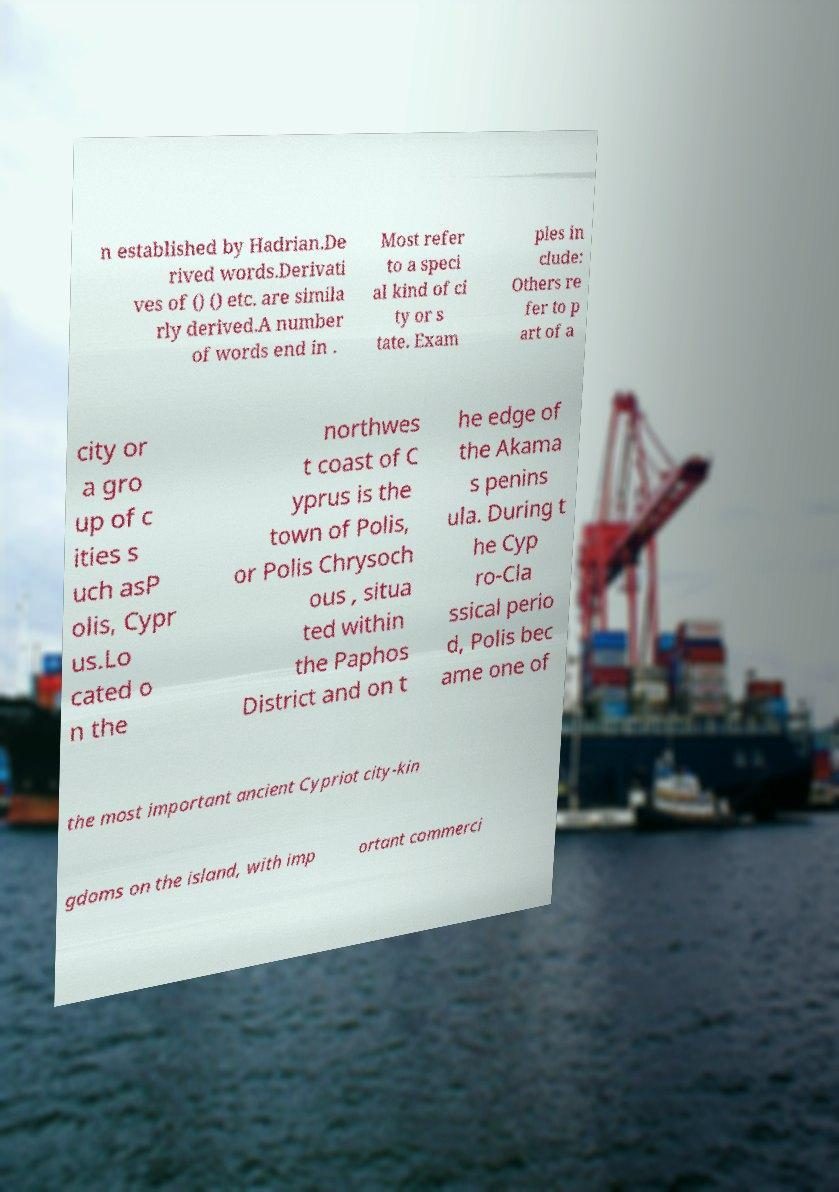I need the written content from this picture converted into text. Can you do that? n established by Hadrian.De rived words.Derivati ves of () () etc. are simila rly derived.A number of words end in . Most refer to a speci al kind of ci ty or s tate. Exam ples in clude: Others re fer to p art of a city or a gro up of c ities s uch asP olis, Cypr us.Lo cated o n the northwes t coast of C yprus is the town of Polis, or Polis Chrysoch ous , situa ted within the Paphos District and on t he edge of the Akama s penins ula. During t he Cyp ro-Cla ssical perio d, Polis bec ame one of the most important ancient Cypriot city-kin gdoms on the island, with imp ortant commerci 